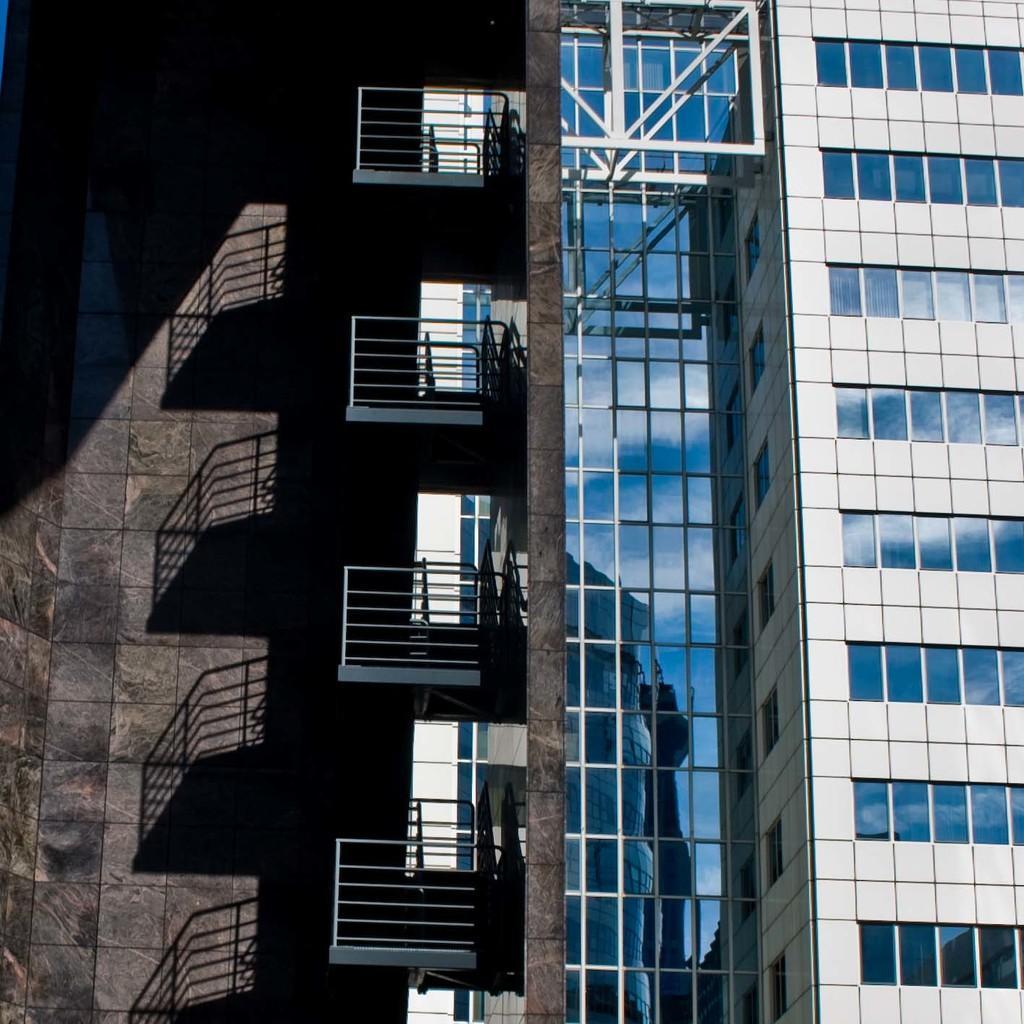Describe this image in one or two sentences. In this image, there is a building which is colored blue and white. There is a wall on the left side of the image. 